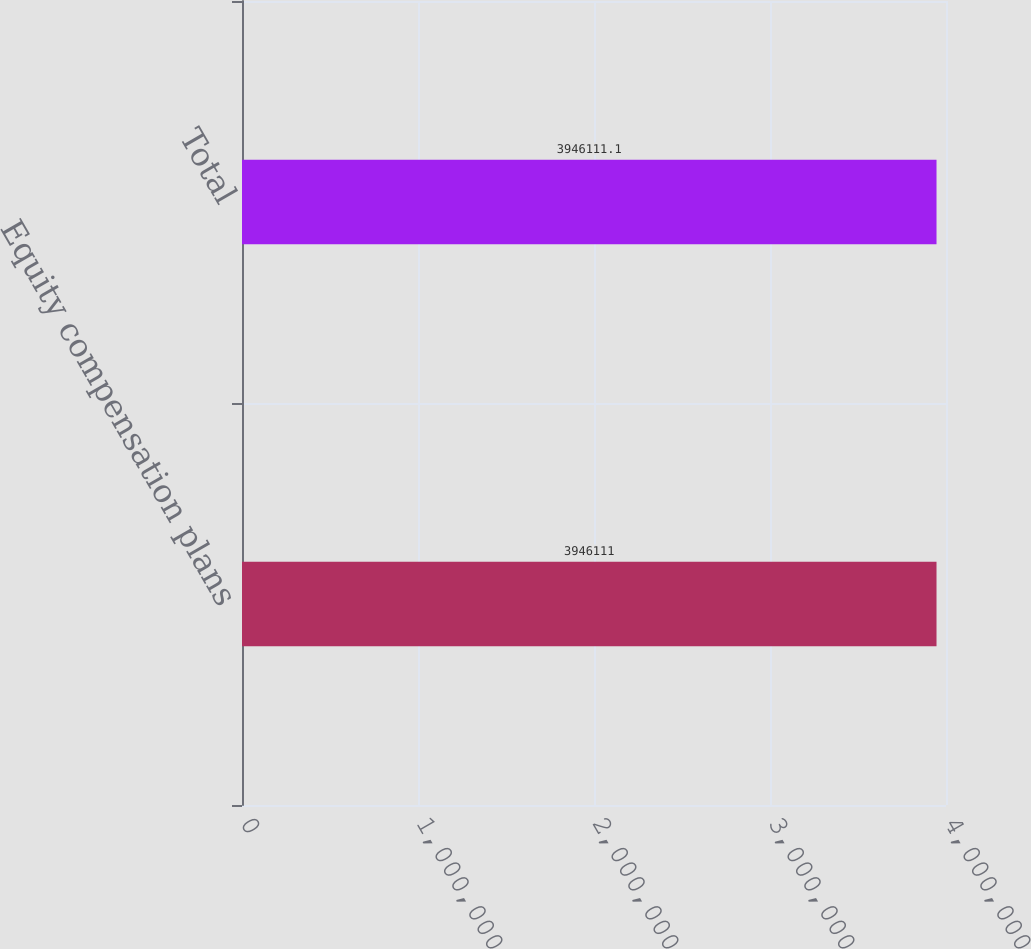Convert chart to OTSL. <chart><loc_0><loc_0><loc_500><loc_500><bar_chart><fcel>Equity compensation plans<fcel>Total<nl><fcel>3.94611e+06<fcel>3.94611e+06<nl></chart> 